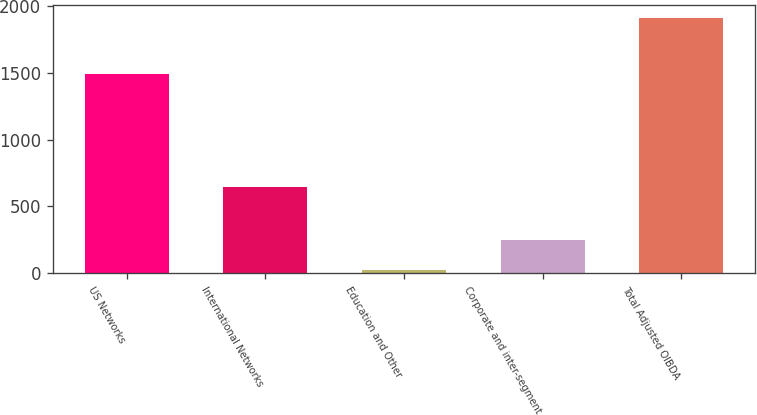<chart> <loc_0><loc_0><loc_500><loc_500><bar_chart><fcel>US Networks<fcel>International Networks<fcel>Education and Other<fcel>Corporate and inter-segment<fcel>Total Adjusted OIBDA<nl><fcel>1495<fcel>645<fcel>23<fcel>249<fcel>1914<nl></chart> 